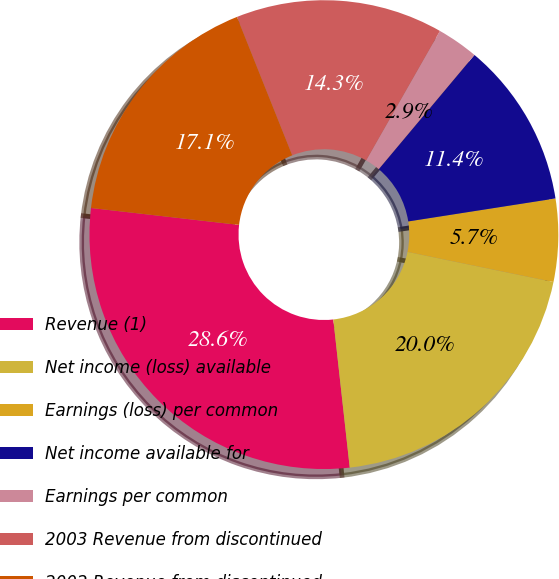Convert chart to OTSL. <chart><loc_0><loc_0><loc_500><loc_500><pie_chart><fcel>Revenue (1)<fcel>Net income (loss) available<fcel>Earnings (loss) per common<fcel>Net income available for<fcel>Earnings per common<fcel>2003 Revenue from discontinued<fcel>2002 Revenue from discontinued<nl><fcel>28.57%<fcel>20.0%<fcel>5.71%<fcel>11.43%<fcel>2.86%<fcel>14.29%<fcel>17.14%<nl></chart> 